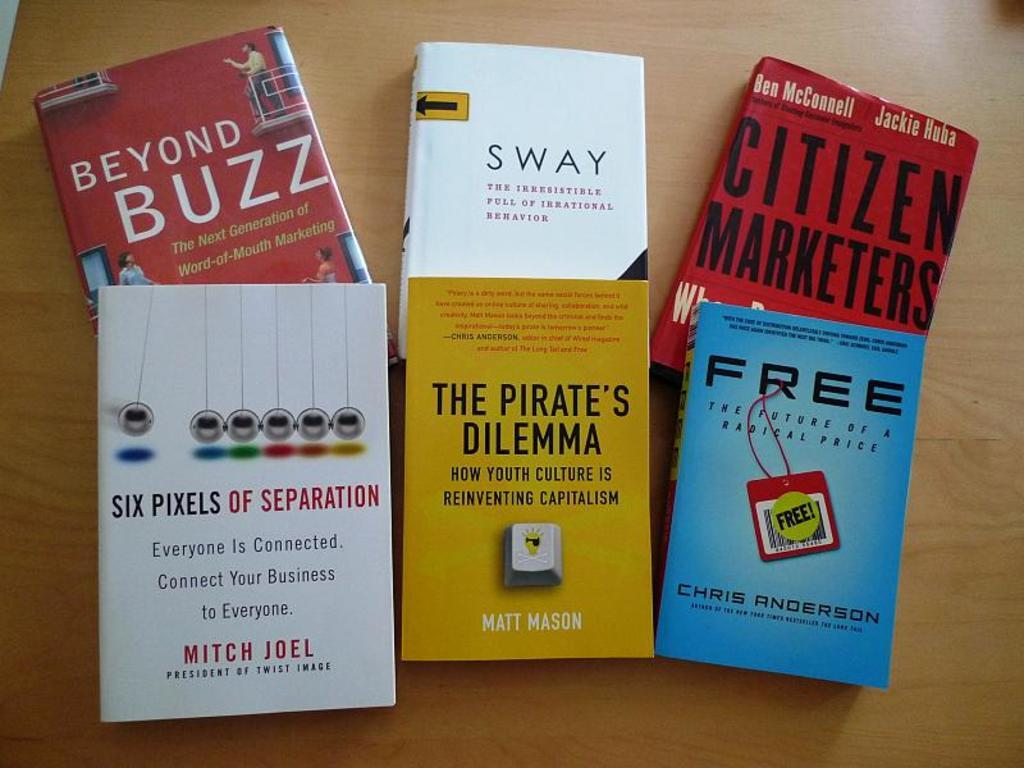<image>
Render a clear and concise summary of the photo. Six books that are based on markets and business. 